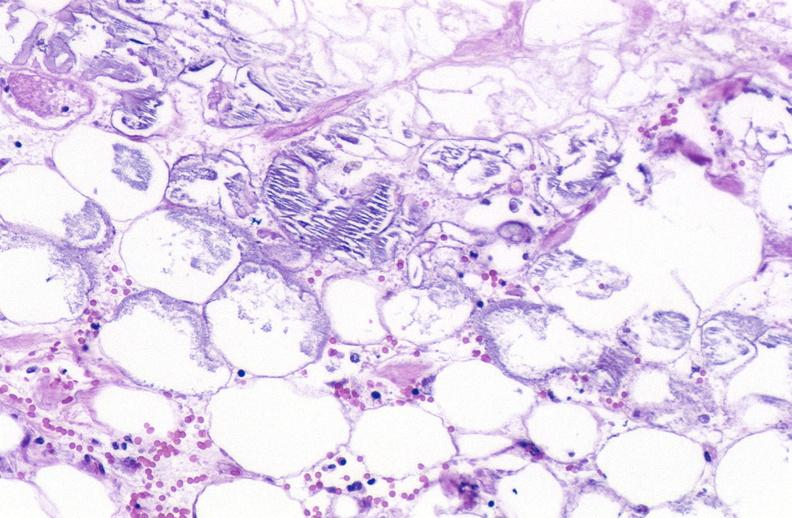where is this?
Answer the question using a single word or phrase. Pancreas 